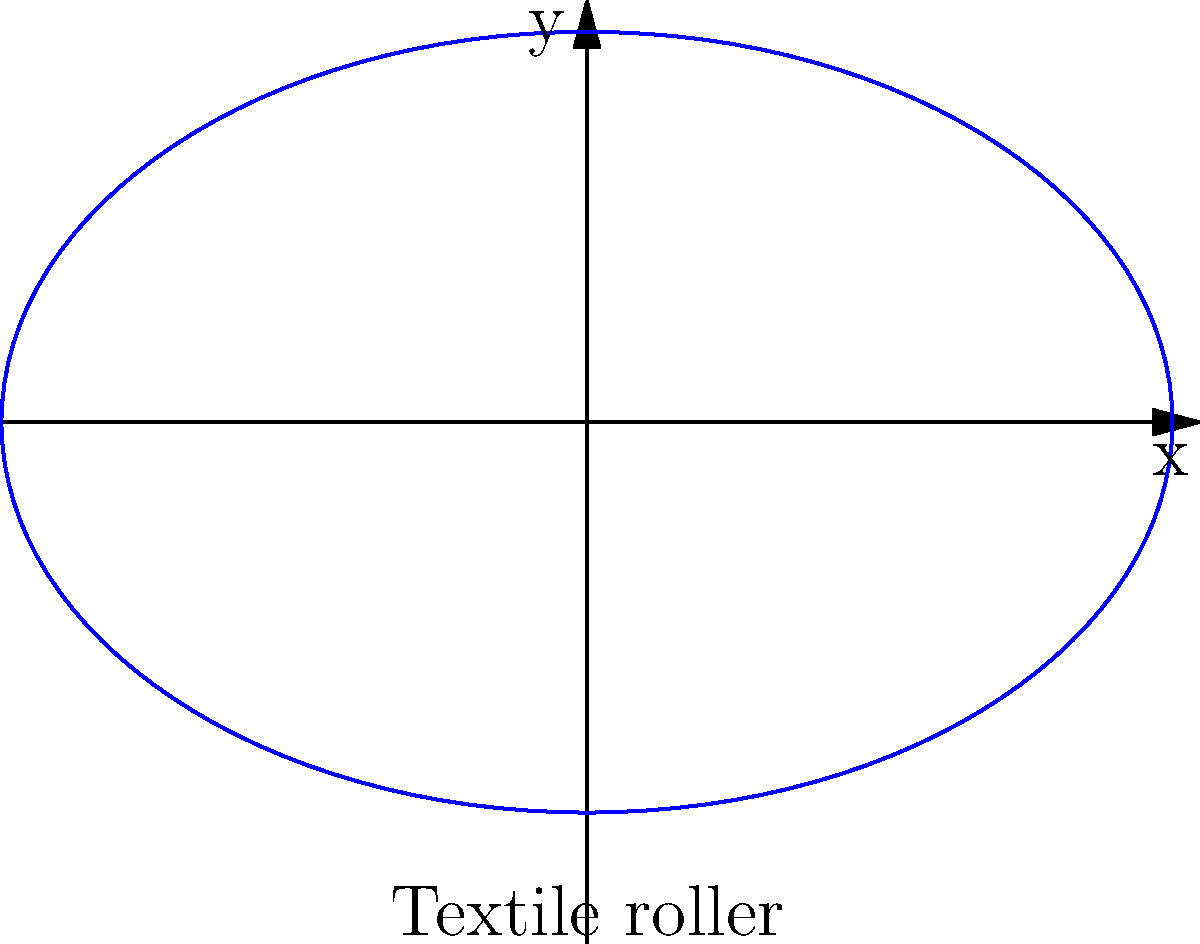A textile roller used in synthetic fabric production can be modeled as an ellipse with semi-major axis $a=3$ units and semi-minor axis $b=2$ units. What is the eccentricity of this ellipse, and how does it relate to the roller's curvature? To find the eccentricity of the ellipse and understand its relation to the roller's curvature, we'll follow these steps:

1) The eccentricity (e) of an ellipse is given by the formula:

   $$e = \sqrt{1 - \frac{b^2}{a^2}}$$

   where $a$ is the semi-major axis and $b$ is the semi-minor axis.

2) Substituting the given values:

   $$e = \sqrt{1 - \frac{2^2}{3^2}}$$

3) Simplify:

   $$e = \sqrt{1 - \frac{4}{9}} = \sqrt{\frac{5}{9}}$$

4) Calculate the final value:

   $$e = \frac{\sqrt{5}}{3} \approx 0.745$$

5) Relation to curvature:
   - The eccentricity is a measure of how much the ellipse deviates from a circle.
   - A lower eccentricity (closer to 0) means the ellipse is more circular, while a higher eccentricity (closer to 1) means it's more elongated.
   - In this case, e ≈ 0.745, which indicates that the roller has a moderately elliptical shape.
   - The curvature of the roller varies along its surface. It's flatter along the major axis and more curved along the minor axis.
   - This variation in curvature could affect the tension and distribution of the synthetic fabric as it passes over the roller during production.
Answer: Eccentricity ≈ 0.745; moderately elliptical shape with varying curvature affecting fabric tension and distribution. 